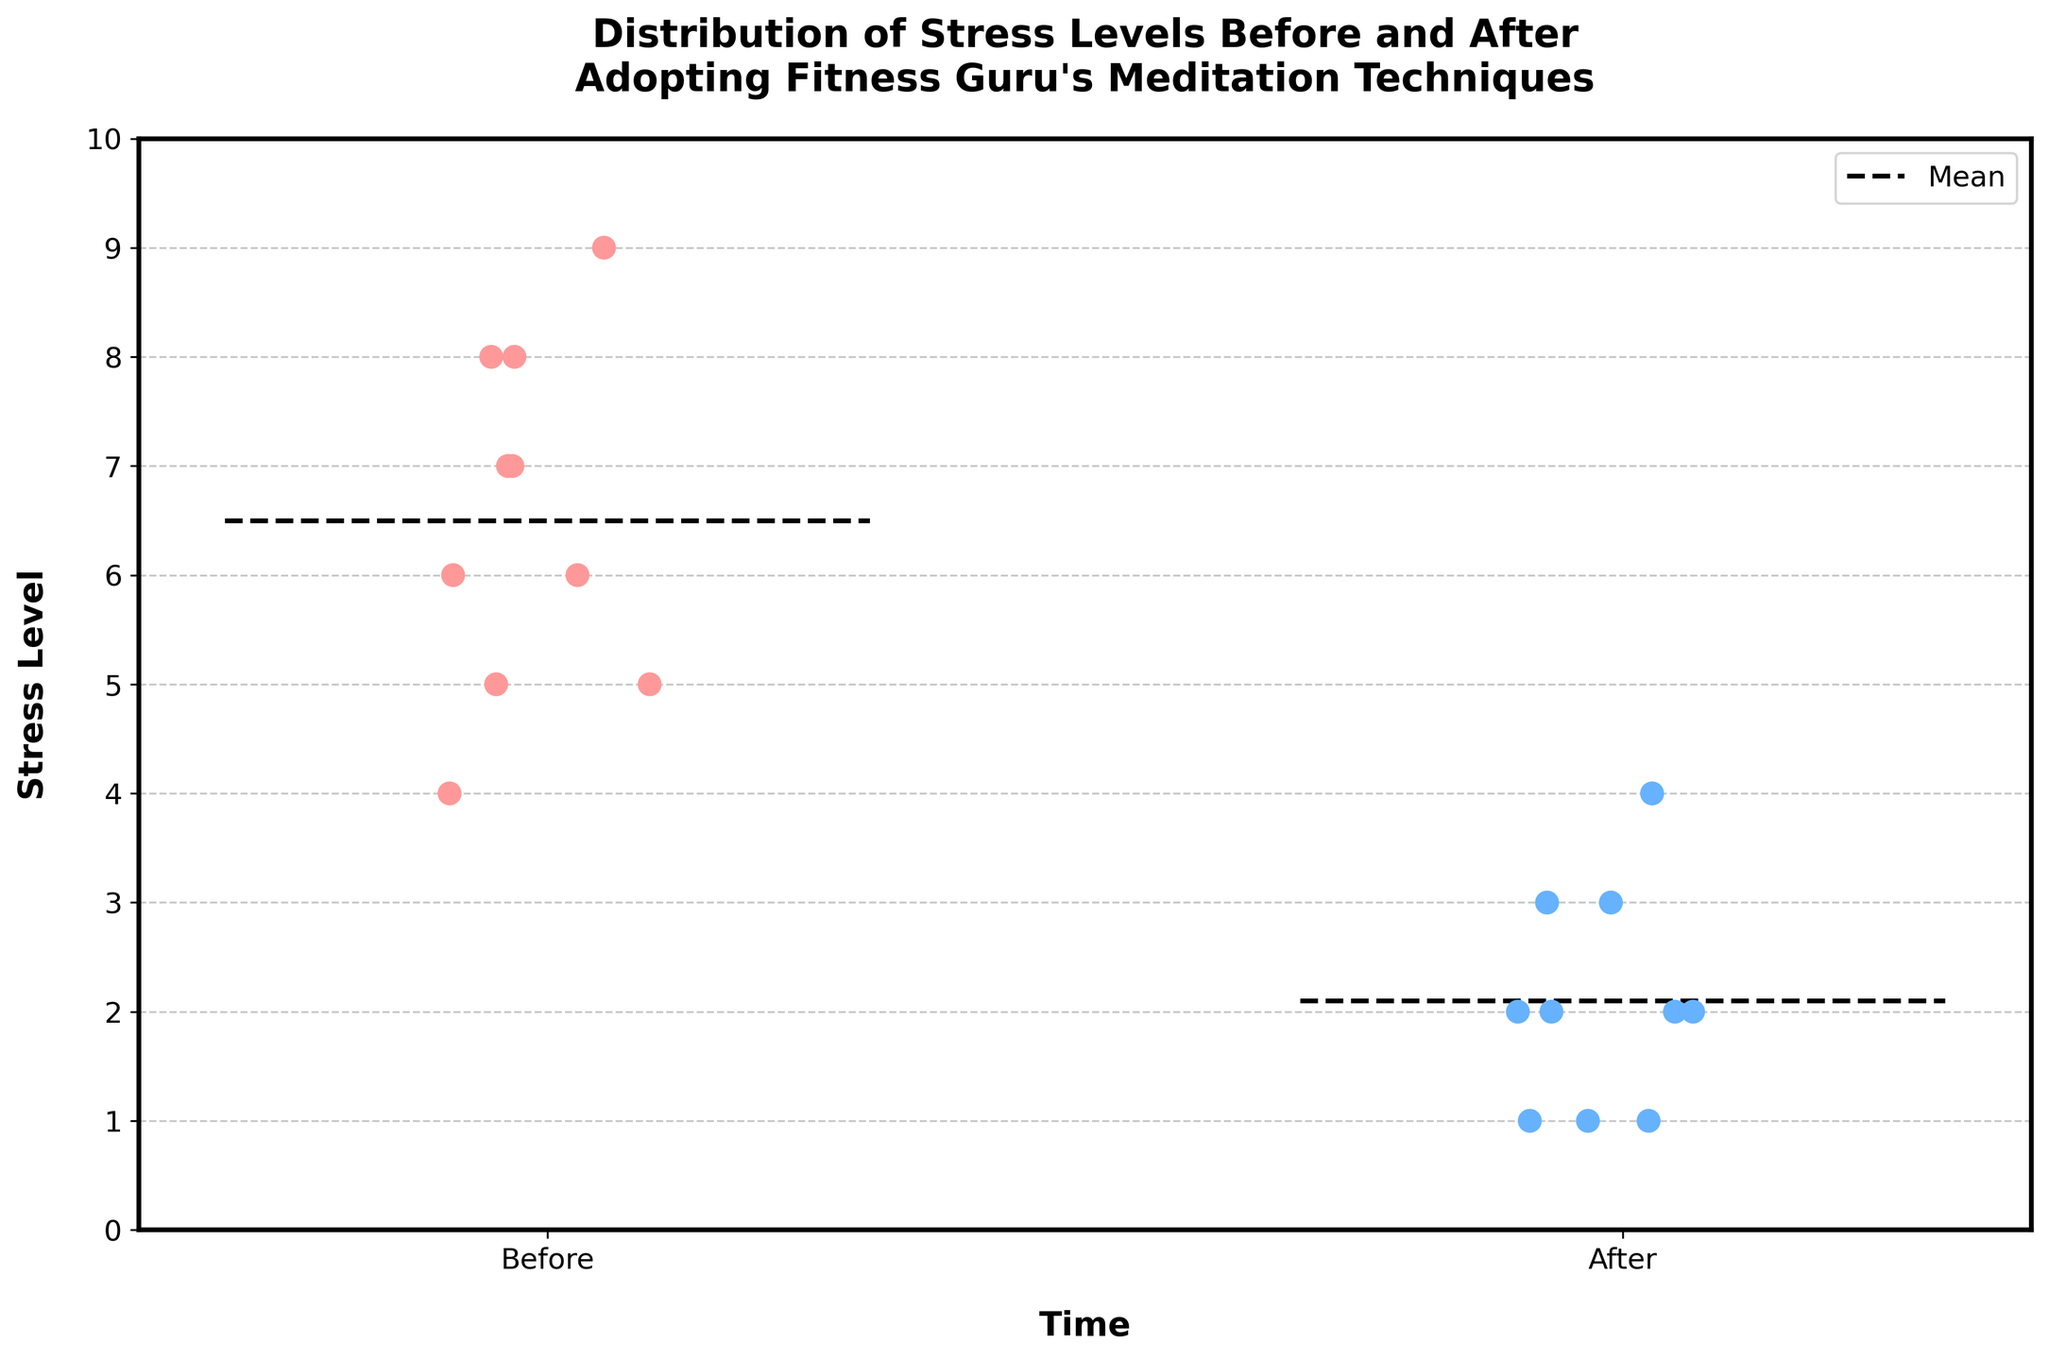What is the title of the figure? The title is often found at the top of the figure and summarizes what the figure is about. In this case, it mentions the stress levels before and after adopting meditation techniques.
Answer: Distribution of Stress Levels Before and After Adopting Fitness Guru's Meditation Techniques How are the stress levels distributed before adopting the meditation techniques? To see the distribution before adopting the techniques, look at the "Before" strip's points' spread and values on the y-axis. Most points are between 5 and 9.
Answer: Most stress levels are high, between 5 and 9 What is the average stress level after adopting the meditation techniques? The average can be seen by the dashed horizontal line in the "After" plot. This line reflects the mean of those data points.
Answer: Around 2.0 How does the number of participants reporting their stress levels before compare with those reporting after? Count the number of points under "Before" and "After" categories. Both should match if participants reported for both times.
Answer: Same number of participants Which participant had the highest stress level before adopting the mediation techniques? Look for the highest point in the "Before" section and check its label.
Answer: Lisa Rodriguez What is the decrease in stress level for Michelle Lee after adopting the meditation techniques? Compare Michelle Lee's stress level before and after. She reported 5 before and 1 after, so subtract the "After" value from the "Before" value.
Answer: 4 Are any participants’ stress levels unchanged after adopting the techniques? Check if any participant has the same stress level before and after in the figure. There should be no overlapping points.
Answer: No Which time period has a lower mean stress level? Compare the mean lines (dashed) of the "Before" and "After" sections. The one lower on the y-axis has a lower mean stress level.
Answer: After How many participants reported a stress level of 2 after adopting the meditation techniques? Count the points on the "After" side at the position where the y-axis value is 2.
Answer: 3 What is the range of stress levels reported before adopting the meditation techniques? Identify the lowest and highest points within the "Before" section and subtract the smallest value from the largest.
Answer: 4 (from 5 to 9) 